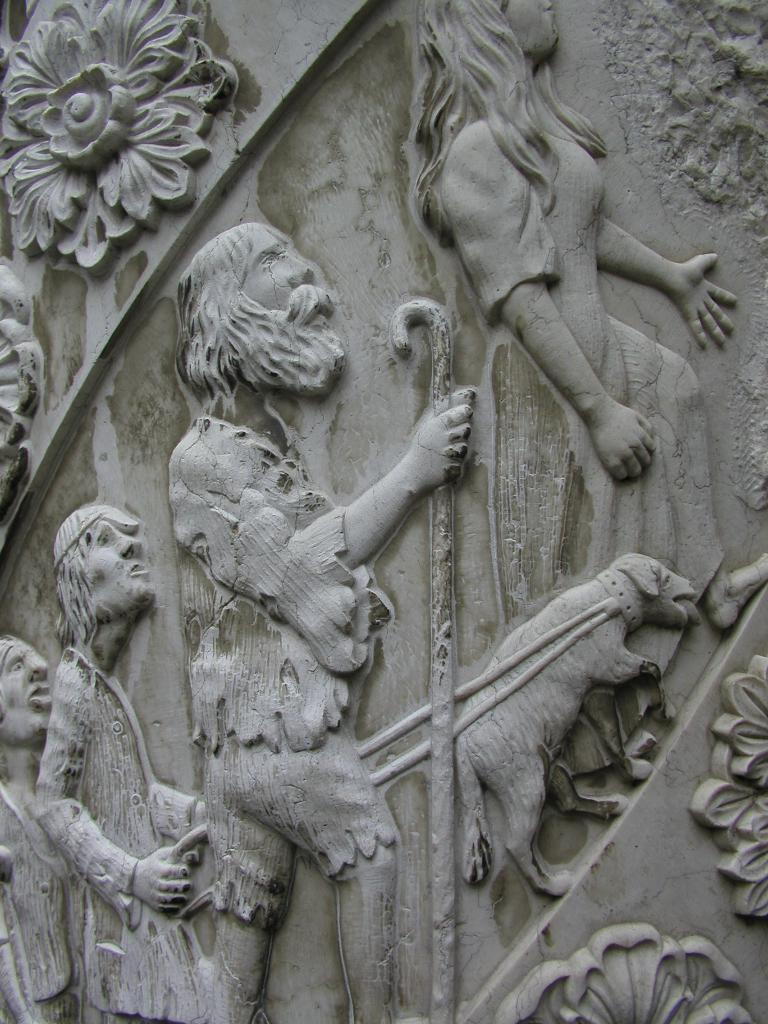What is present on the wall in the image? There are sculptures on the wall in the image. What type of steel is used to create the fifth sculpture in the image? There is no information about the type of steel or the number of sculptures in the image, as it only mentions that there are sculptures on the wall. 